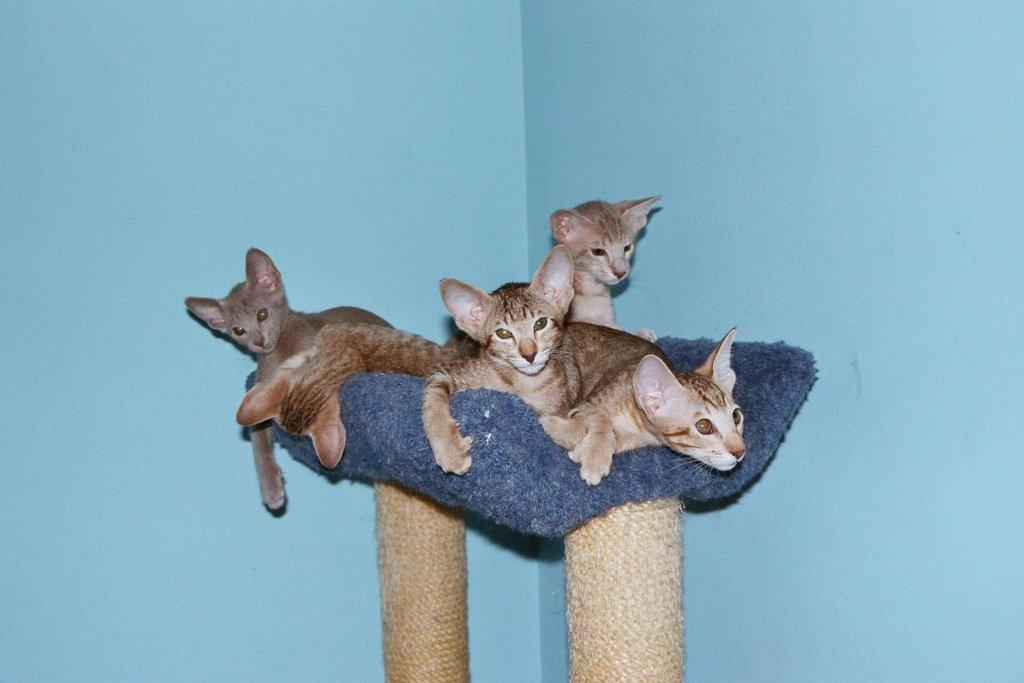What objects can be seen standing upright in the image? There are poles in the image. What animals are present on a cloth in the image? There is a group of cats on a cloth in the image. What type of structures can be seen in the background of the image? There are walls visible in the background of the image. How does the wave of muscle impact the cats in the image? There is no wave of muscle present in the image, and therefore no impact on the cats can be observed. 